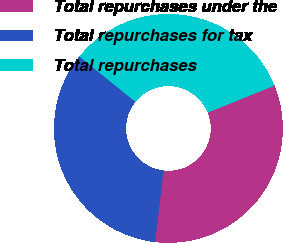Convert chart. <chart><loc_0><loc_0><loc_500><loc_500><pie_chart><fcel>Total repurchases under the<fcel>Total repurchases for tax<fcel>Total repurchases<nl><fcel>32.97%<fcel>33.95%<fcel>33.07%<nl></chart> 